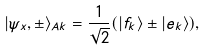<formula> <loc_0><loc_0><loc_500><loc_500>| \psi _ { x } , \pm \rangle _ { A k } = \frac { 1 } { \sqrt { 2 } } ( | f _ { k } \rangle \pm | e _ { k } \rangle ) ,</formula> 